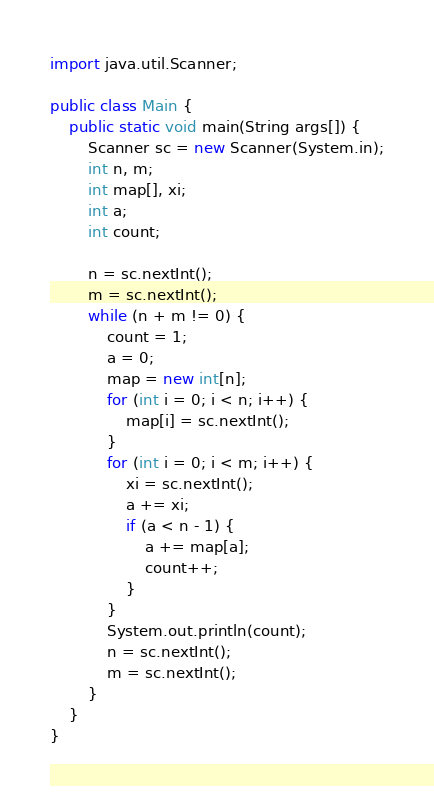Convert code to text. <code><loc_0><loc_0><loc_500><loc_500><_Java_>import java.util.Scanner;

public class Main {
	public static void main(String args[]) {
		Scanner sc = new Scanner(System.in);
		int n, m;
		int map[], xi;
		int a;
		int count;

		n = sc.nextInt();
		m = sc.nextInt();
		while (n + m != 0) {
			count = 1;
			a = 0;
			map = new int[n];
			for (int i = 0; i < n; i++) {
				map[i] = sc.nextInt();
			}
			for (int i = 0; i < m; i++) {
				xi = sc.nextInt();
				a += xi;
				if (a < n - 1) {
					a += map[a];
					count++;
				}
			}
			System.out.println(count);
			n = sc.nextInt();
			m = sc.nextInt();
		}
	}
}</code> 